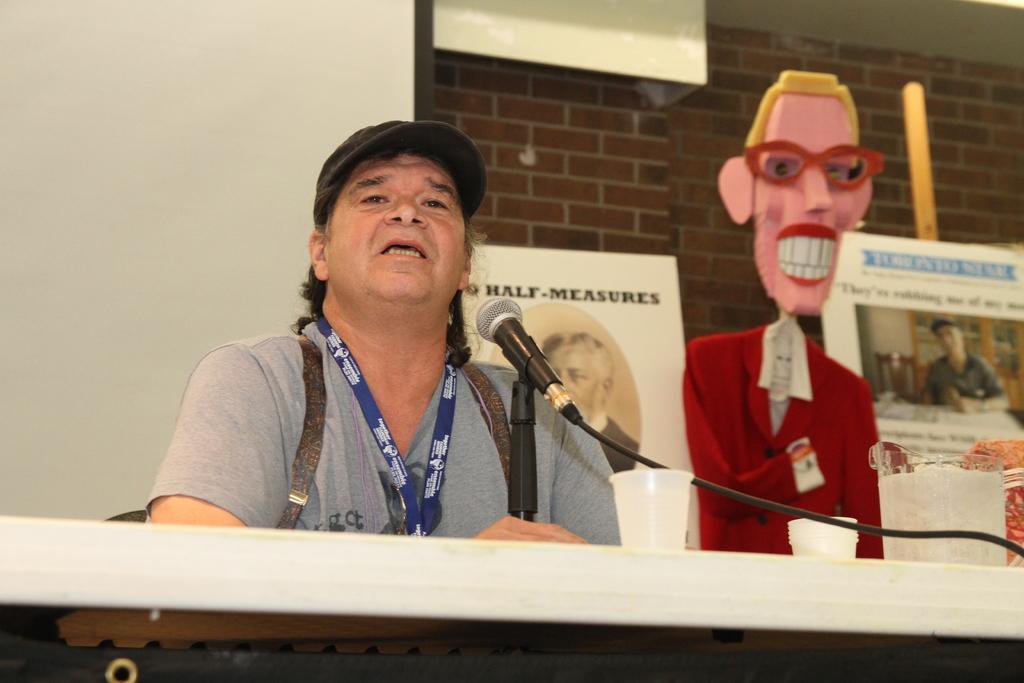Please provide a concise description of this image. In this image I can see a man and I can see he is wearing grey colour t shirt, a cap and around his neck I can see a blue colour thing. In the front of him I can see a mic, few glasses and a white colour thing. In the background I can see a doll, few posters and I can see this doll is wearing red colour dress. On these posters I can see something is written. 